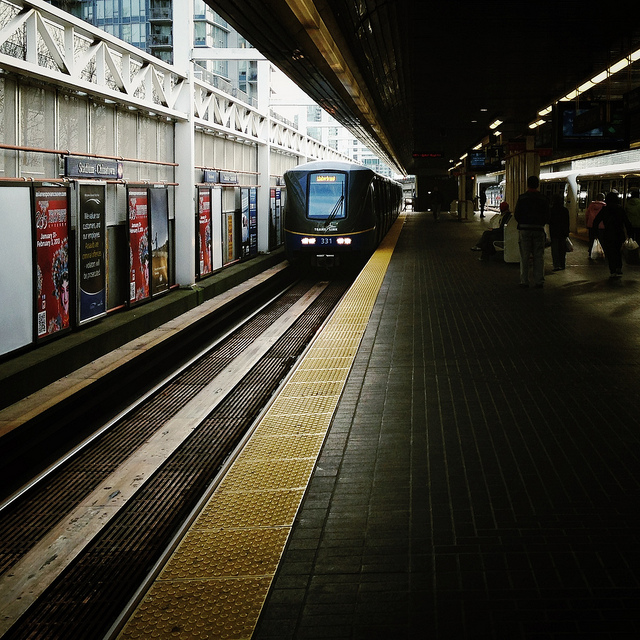<image>Why the train didn't stop? It is unknown why the train didn't stop. It could be due to lack of passengers or the train doesn't stop at the location in the image. Why the train didn't stop? It is ambiguous why the train didn't stop. There can be multiple reasons such as "no passengers", "no one", "taking off", "moving", "doesn't stop here" or "didn't have time". 